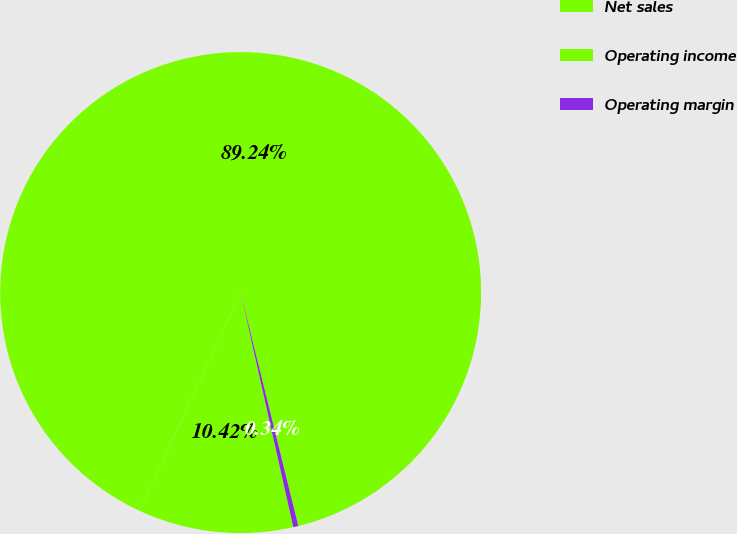<chart> <loc_0><loc_0><loc_500><loc_500><pie_chart><fcel>Net sales<fcel>Operating income<fcel>Operating margin<nl><fcel>89.24%<fcel>10.42%<fcel>0.34%<nl></chart> 